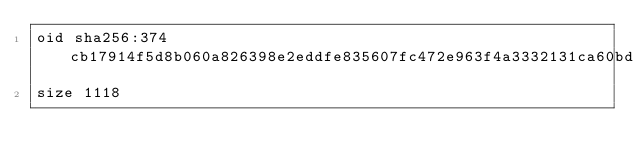<code> <loc_0><loc_0><loc_500><loc_500><_YAML_>oid sha256:374cb17914f5d8b060a826398e2eddfe835607fc472e963f4a3332131ca60bd9
size 1118
</code> 